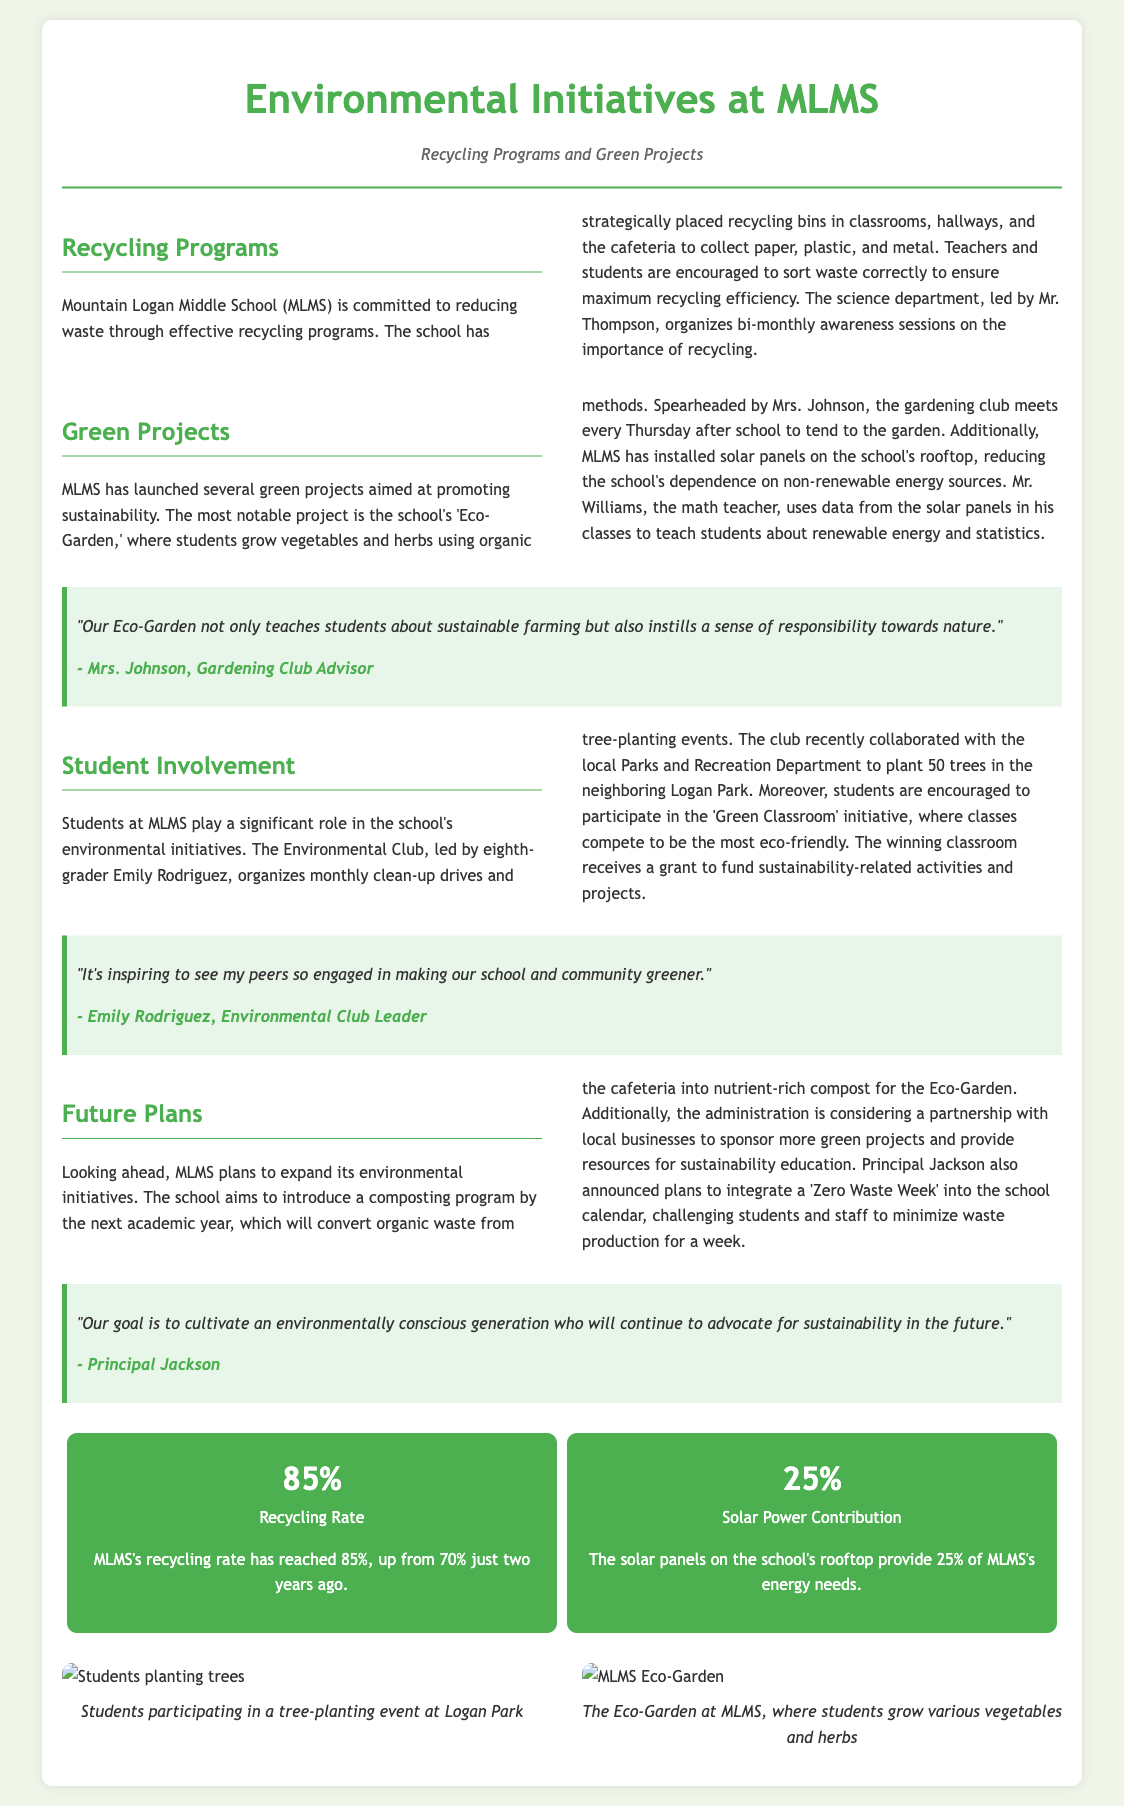What is the recycling rate at MLMS? The document states that MLMS's recycling rate has reached 85%.
Answer: 85% Who leads the Gardening Club at MLMS? The document mentions that the Gardening Club is led by Mrs. Johnson.
Answer: Mrs. Johnson What project do students work on every Thursday? The Eco-Garden is where students meet every Thursday after school.
Answer: Eco-Garden How many trees were planted in collaboration with the local Parks and Recreation Department? The document states that 50 trees were planted in Logan Park.
Answer: 50 What is the percentage contribution of solar power to MLMS's energy needs? The document specifies that the solar panels provide 25% of MLMS's energy needs.
Answer: 25% What initiative involves classes competing to be the most eco-friendly? The initiative is called the 'Green Classroom'.
Answer: 'Green Classroom' Who is the eighth-grader leading the Environmental Club? Emily Rodriguez is identified as the leader of the Environmental Club.
Answer: Emily Rodriguez What is one future initiative planned by MLMS? The document outlines plans to introduce a composting program.
Answer: composting program Who made a statement about cultivating an environmentally conscious generation? Principal Jackson is quoted regarding this goal.
Answer: Principal Jackson 